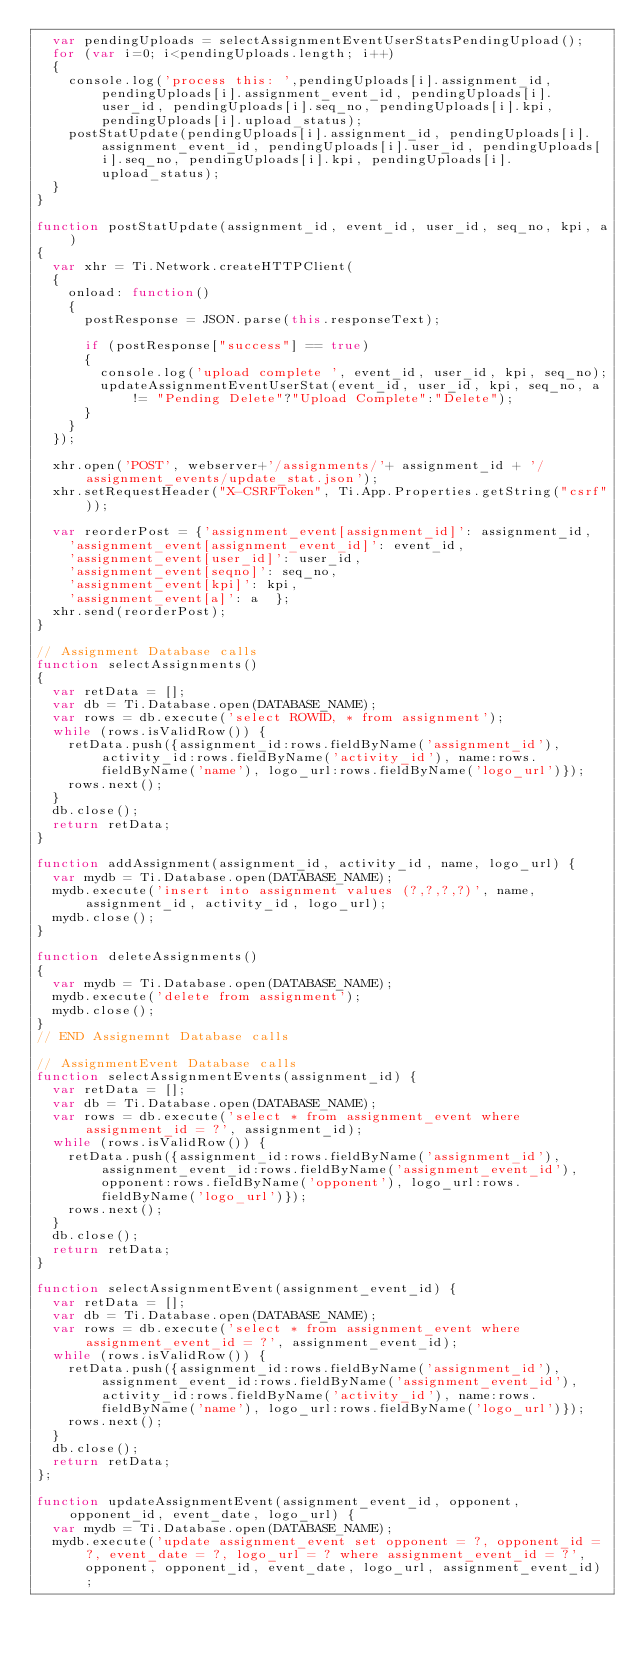Convert code to text. <code><loc_0><loc_0><loc_500><loc_500><_JavaScript_>	var pendingUploads = selectAssignmentEventUserStatsPendingUpload();
	for (var i=0; i<pendingUploads.length; i++)
	{
		console.log('process this: ',pendingUploads[i].assignment_id, pendingUploads[i].assignment_event_id, pendingUploads[i].user_id, pendingUploads[i].seq_no, pendingUploads[i].kpi, pendingUploads[i].upload_status);
		postStatUpdate(pendingUploads[i].assignment_id, pendingUploads[i].assignment_event_id, pendingUploads[i].user_id, pendingUploads[i].seq_no, pendingUploads[i].kpi, pendingUploads[i].upload_status);
	}
}

function postStatUpdate(assignment_id, event_id, user_id, seq_no, kpi, a)
{
	var xhr = Ti.Network.createHTTPClient(
	{
		onload: function() 
		{
			postResponse = JSON.parse(this.responseText);
			
			if (postResponse["success"] == true)
			{
				console.log('upload complete ', event_id, user_id, kpi, seq_no);
				updateAssignmentEventUserStat(event_id, user_id, kpi, seq_no, a != "Pending Delete"?"Upload Complete":"Delete");
			}
		}
	});
	
	xhr.open('POST', webserver+'/assignments/'+ assignment_id + '/assignment_events/update_stat.json');
	xhr.setRequestHeader("X-CSRFToken", Ti.App.Properties.getString("csrf"));
	
	var reorderPost = {'assignment_event[assignment_id]': assignment_id, 
		'assignment_event[assignment_event_id]': event_id, 
		'assignment_event[user_id]': user_id, 
		'assignment_event[seqno]': seq_no,
		'assignment_event[kpi]': kpi, 
		'assignment_event[a]': a  };
	xhr.send(reorderPost);
}

// Assignment Database calls
function selectAssignments()
{
	var retData = [];
	var db = Ti.Database.open(DATABASE_NAME);
	var rows = db.execute('select ROWID, * from assignment');
	while (rows.isValidRow()) {
		retData.push({assignment_id:rows.fieldByName('assignment_id'), activity_id:rows.fieldByName('activity_id'), name:rows.fieldByName('name'), logo_url:rows.fieldByName('logo_url')});
		rows.next();
	}
	db.close();
	return retData;
}

function addAssignment(assignment_id, activity_id, name, logo_url) {
	var mydb = Ti.Database.open(DATABASE_NAME);
	mydb.execute('insert into assignment values (?,?,?,?)', name, assignment_id, activity_id, logo_url);
	mydb.close();
}

function deleteAssignments() 
{
	var mydb = Ti.Database.open(DATABASE_NAME);
	mydb.execute('delete from assignment');
	mydb.close();
}
// END Assignemnt Database calls

// AssignmentEvent Database calls
function selectAssignmentEvents(assignment_id) {
	var retData = [];
	var db = Ti.Database.open(DATABASE_NAME);
	var rows = db.execute('select * from assignment_event where assignment_id = ?', assignment_id);
	while (rows.isValidRow()) {
		retData.push({assignment_id:rows.fieldByName('assignment_id'), assignment_event_id:rows.fieldByName('assignment_event_id'), opponent:rows.fieldByName('opponent'), logo_url:rows.fieldByName('logo_url')});
		rows.next();
	}
	db.close();
	return retData;
}

function selectAssignmentEvent(assignment_event_id) {
	var retData = [];
	var db = Ti.Database.open(DATABASE_NAME);
	var rows = db.execute('select * from assignment_event where assignment_event_id = ?', assignment_event_id);
	while (rows.isValidRow()) {
		retData.push({assignment_id:rows.fieldByName('assignment_id'), assignment_event_id:rows.fieldByName('assignment_event_id'), activity_id:rows.fieldByName('activity_id'), name:rows.fieldByName('name'), logo_url:rows.fieldByName('logo_url')});
		rows.next();
	}
	db.close();
	return retData;
};

function updateAssignmentEvent(assignment_event_id, opponent, opponent_id, event_date, logo_url) { 
	var mydb = Ti.Database.open(DATABASE_NAME);
	mydb.execute('update assignment_event set opponent = ?, opponent_id = ?, event_date = ?, logo_url = ? where assignment_event_id = ?', opponent, opponent_id, event_date, logo_url, assignment_event_id);</code> 